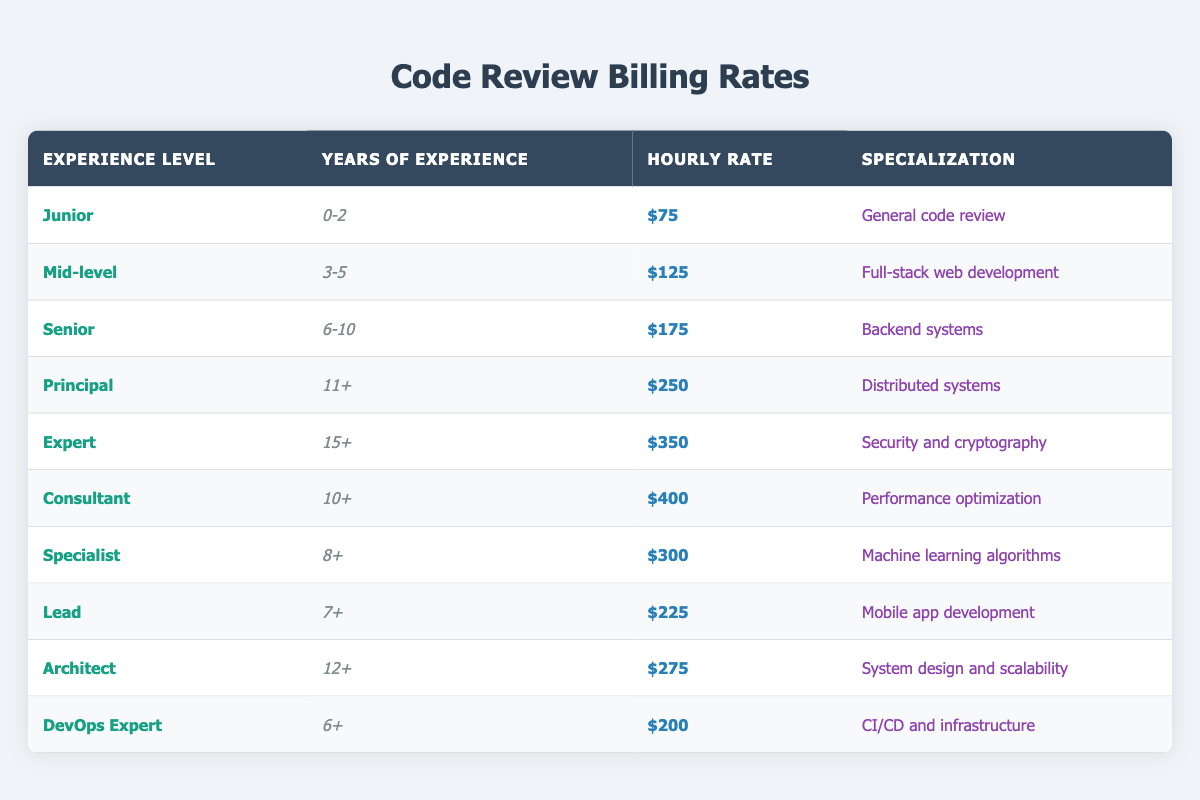What is the hourly rate for a Junior code review expert? The table shows that the hourly rate for a Junior is $75.
Answer: $75 What specialization does a Principal code reviewer have? The specialization for a Principal code reviewer listed in the table is Distributed systems.
Answer: Distributed systems How many code review roles have an hourly rate of $200 or more? By examining the table, there are five roles (Principal, Expert, Consultant, Specialist, Lead) with hourly rates of $200 or more: Principal at $250, Expert at $350, Consultant at $400, Specialist at $300, and Lead at $225. This results in 5 roles.
Answer: 5 What is the difference in hourly rates between an Expert and a Junior reviewer? From the table, the hourly rate for an Expert is $350, and that for a Junior is $75. Therefore, the difference is $350 - $75 = $275.
Answer: $275 Is the hourly rate for a DevOps Expert less than the rate for a Senior reviewer? The hourly rate for a DevOps Expert is $200, and for a Senior reviewer, it is $175. Since $200 is greater than $175, the statement is false.
Answer: No What is the highest hourly rate among all the roles listed in the table? Upon reviewing the table data, the highest hourly rate is for a Consultant at $400.
Answer: $400 How does the specialization of a Lead compare to that of a Specialist in years of experience? The table specifies that a Lead has 7+ years of experience and a Specialist has 8+ years. Comparing these, the Specialist requires more experience than the Lead.
Answer: Specialist has more experience If you were to calculate the average hourly rate of all reviewers listed, what would that be? To find the average, we first sum the hourly rates: $75 + $125 + $175 + $250 + $350 + $400 + $300 + $225 + $275 + $200 = $1875. There are 10 roles, so the average is $1875 / 10 = $187.50.
Answer: $187.50 How many years of experience does the Consultant role require? The table shows that the Consultant role requires 10+ years of experience.
Answer: 10+ years 